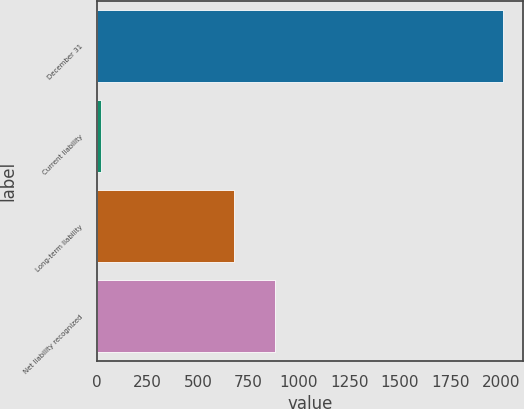Convert chart to OTSL. <chart><loc_0><loc_0><loc_500><loc_500><bar_chart><fcel>December 31<fcel>Current liability<fcel>Long-term liability<fcel>Net liability recognized<nl><fcel>2010<fcel>21<fcel>681<fcel>879.9<nl></chart> 